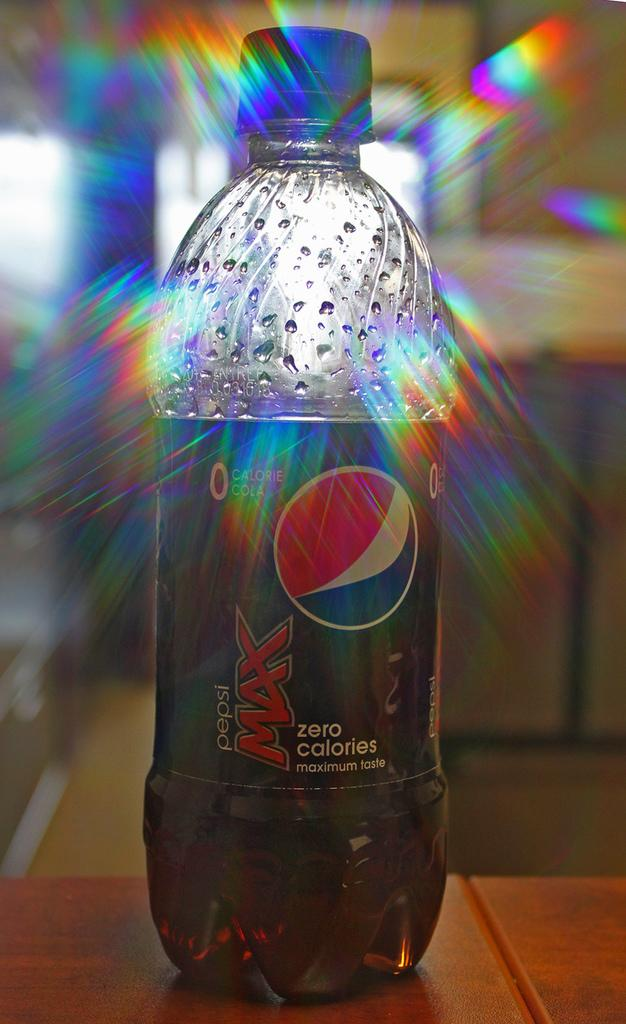<image>
Render a clear and concise summary of the photo. a bottle of pepsi max zero caleries standing in direct sunlight 